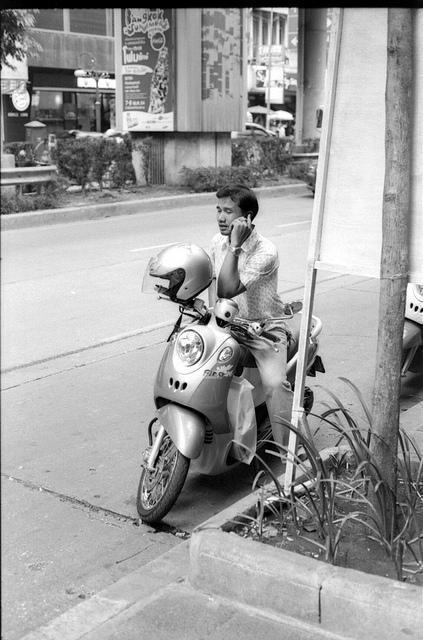What has the man stopped on his scooter?
Choose the correct response, then elucidate: 'Answer: answer
Rationale: rationale.'
Options: Accident, traffic, floods, phone call. Answer: phone call.
Rationale: The man is holding a phone to their ear. 